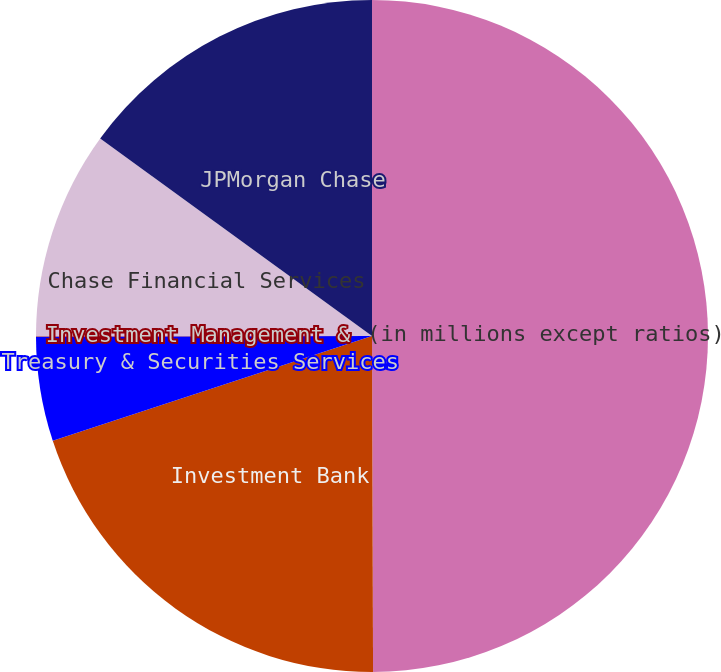Convert chart. <chart><loc_0><loc_0><loc_500><loc_500><pie_chart><fcel>(in millions except ratios)<fcel>Investment Bank<fcel>Treasury & Securities Services<fcel>Investment Management &<fcel>Chase Financial Services<fcel>JPMorgan Chase<nl><fcel>49.95%<fcel>20.0%<fcel>5.02%<fcel>0.02%<fcel>10.01%<fcel>15.0%<nl></chart> 